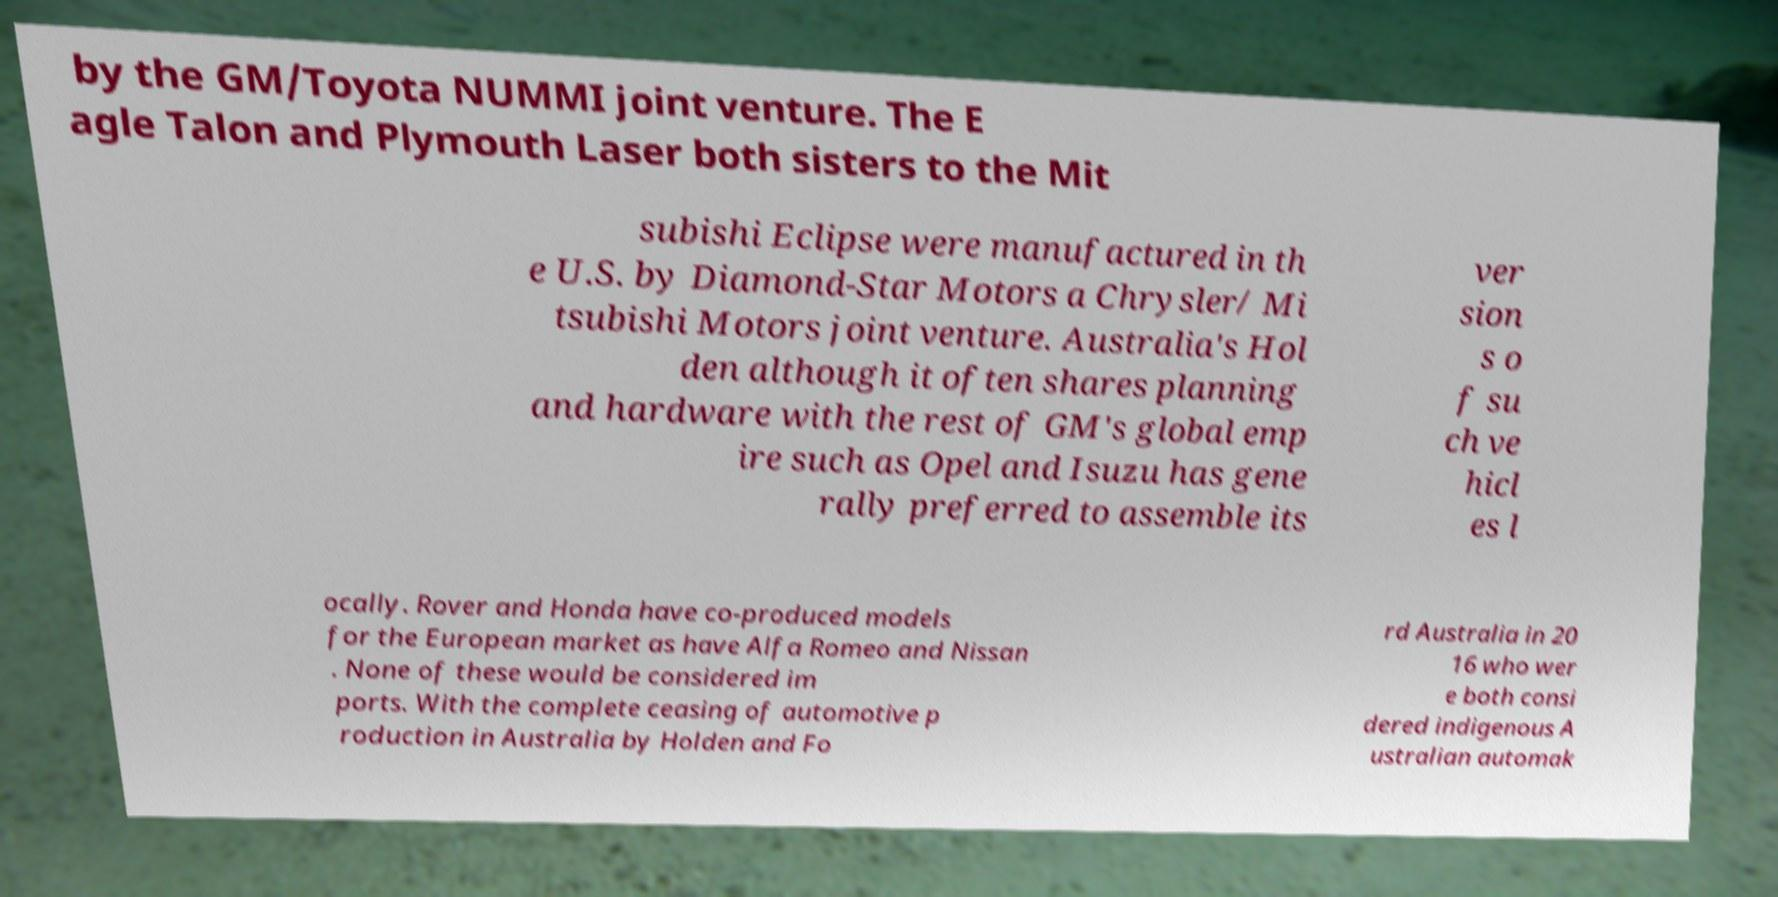What messages or text are displayed in this image? I need them in a readable, typed format. by the GM/Toyota NUMMI joint venture. The E agle Talon and Plymouth Laser both sisters to the Mit subishi Eclipse were manufactured in th e U.S. by Diamond-Star Motors a Chrysler/ Mi tsubishi Motors joint venture. Australia's Hol den although it often shares planning and hardware with the rest of GM's global emp ire such as Opel and Isuzu has gene rally preferred to assemble its ver sion s o f su ch ve hicl es l ocally. Rover and Honda have co-produced models for the European market as have Alfa Romeo and Nissan . None of these would be considered im ports. With the complete ceasing of automotive p roduction in Australia by Holden and Fo rd Australia in 20 16 who wer e both consi dered indigenous A ustralian automak 